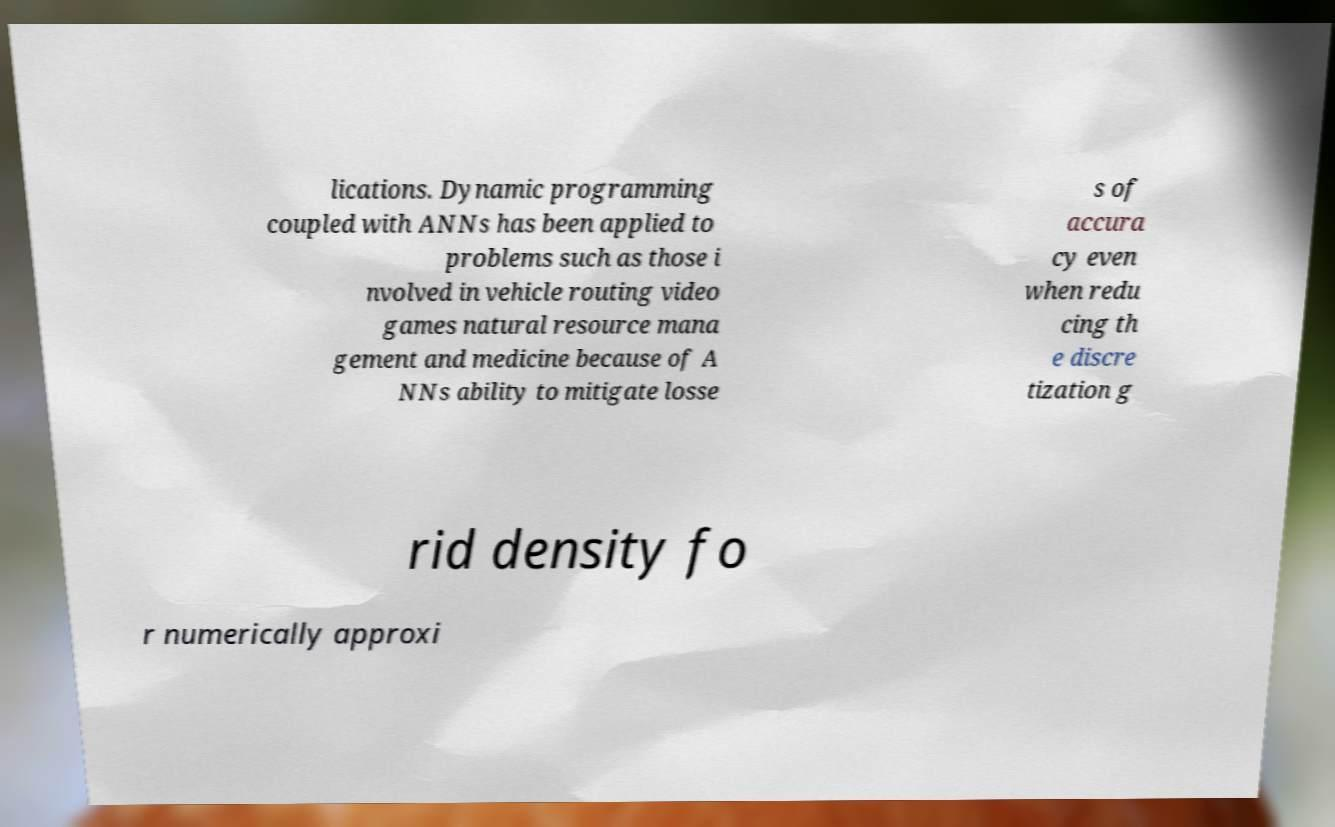What messages or text are displayed in this image? I need them in a readable, typed format. lications. Dynamic programming coupled with ANNs has been applied to problems such as those i nvolved in vehicle routing video games natural resource mana gement and medicine because of A NNs ability to mitigate losse s of accura cy even when redu cing th e discre tization g rid density fo r numerically approxi 